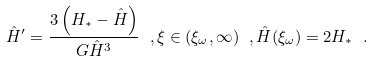<formula> <loc_0><loc_0><loc_500><loc_500>\hat { H } ^ { \prime } = \frac { 3 \left ( H _ { * } - \hat { H } \right ) } { G \hat { H } ^ { 3 } } \ , \xi \in ( \xi _ { \omega } , \infty ) \ , \hat { H } ( \xi _ { \omega } ) = 2 H _ { * } \ .</formula> 